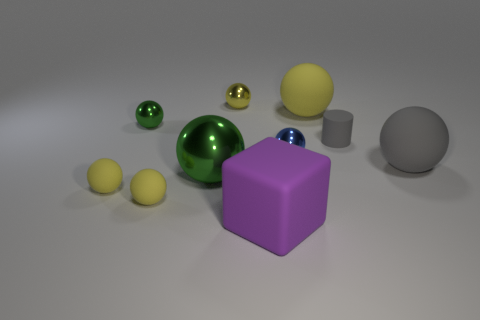How many yellow balls must be subtracted to get 1 yellow balls? 3 Subtract all small metallic balls. How many balls are left? 5 Subtract 2 balls. How many balls are left? 6 Subtract all gray balls. How many balls are left? 7 Subtract all cylinders. How many objects are left? 9 Add 2 large green shiny spheres. How many large green shiny spheres exist? 3 Subtract 0 purple spheres. How many objects are left? 10 Subtract all gray blocks. Subtract all green cylinders. How many blocks are left? 1 Subtract all blue cylinders. How many blue balls are left? 1 Subtract all large cyan matte cylinders. Subtract all big gray balls. How many objects are left? 9 